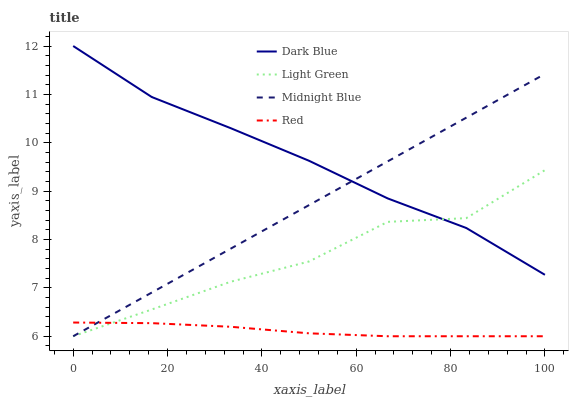Does Red have the minimum area under the curve?
Answer yes or no. Yes. Does Dark Blue have the maximum area under the curve?
Answer yes or no. Yes. Does Midnight Blue have the minimum area under the curve?
Answer yes or no. No. Does Midnight Blue have the maximum area under the curve?
Answer yes or no. No. Is Midnight Blue the smoothest?
Answer yes or no. Yes. Is Light Green the roughest?
Answer yes or no. Yes. Is Red the smoothest?
Answer yes or no. No. Is Red the roughest?
Answer yes or no. No. Does Red have the lowest value?
Answer yes or no. Yes. Does Light Green have the lowest value?
Answer yes or no. No. Does Dark Blue have the highest value?
Answer yes or no. Yes. Does Midnight Blue have the highest value?
Answer yes or no. No. Is Red less than Dark Blue?
Answer yes or no. Yes. Is Dark Blue greater than Red?
Answer yes or no. Yes. Does Dark Blue intersect Midnight Blue?
Answer yes or no. Yes. Is Dark Blue less than Midnight Blue?
Answer yes or no. No. Is Dark Blue greater than Midnight Blue?
Answer yes or no. No. Does Red intersect Dark Blue?
Answer yes or no. No. 